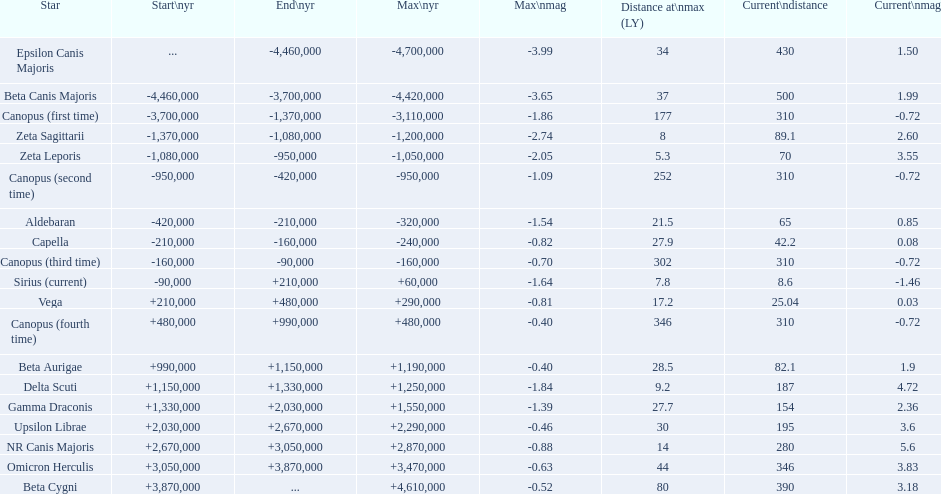What are the historical brightest stars? Epsilon Canis Majoris, Beta Canis Majoris, Canopus (first time), Zeta Sagittarii, Zeta Leporis, Canopus (second time), Aldebaran, Capella, Canopus (third time), Sirius (current), Vega, Canopus (fourth time), Beta Aurigae, Delta Scuti, Gamma Draconis, Upsilon Librae, NR Canis Majoris, Omicron Herculis, Beta Cygni. Of those which star has a distance at maximum of 80 Beta Cygni. 